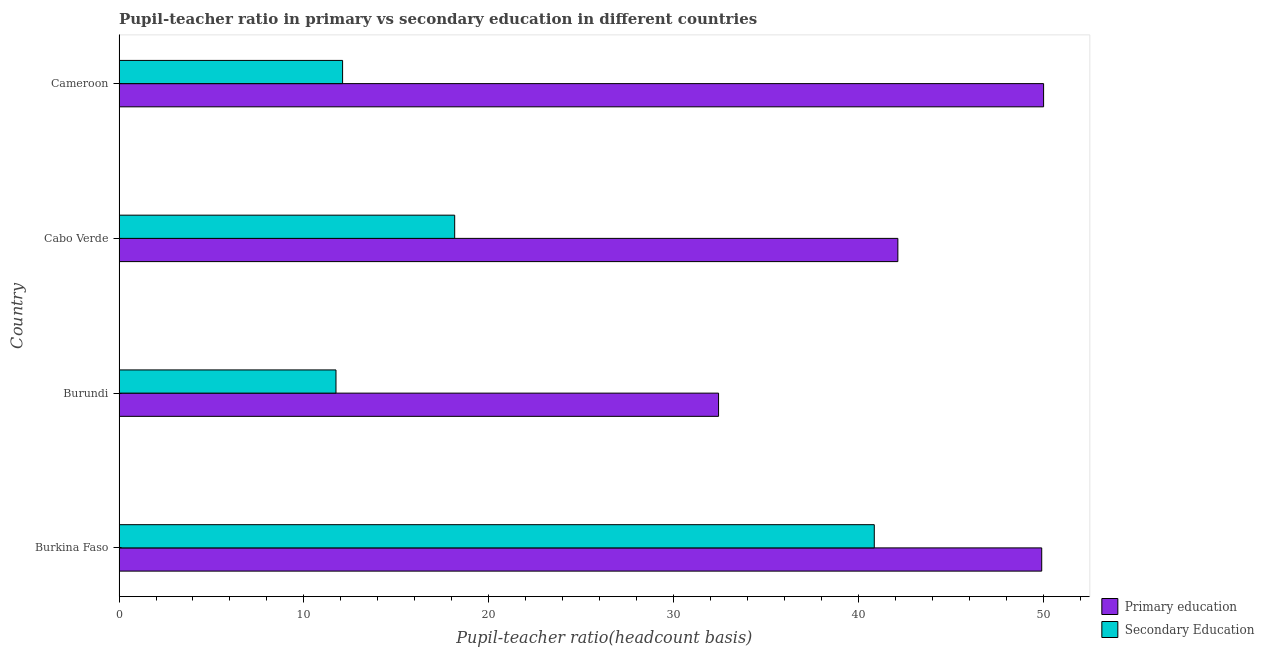How many groups of bars are there?
Ensure brevity in your answer.  4. Are the number of bars per tick equal to the number of legend labels?
Provide a succinct answer. Yes. How many bars are there on the 1st tick from the top?
Keep it short and to the point. 2. How many bars are there on the 4th tick from the bottom?
Offer a very short reply. 2. What is the label of the 2nd group of bars from the top?
Provide a short and direct response. Cabo Verde. In how many cases, is the number of bars for a given country not equal to the number of legend labels?
Provide a short and direct response. 0. What is the pupil teacher ratio on secondary education in Burundi?
Your answer should be compact. 11.74. Across all countries, what is the maximum pupil-teacher ratio in primary education?
Keep it short and to the point. 50.02. Across all countries, what is the minimum pupil-teacher ratio in primary education?
Give a very brief answer. 32.44. In which country was the pupil teacher ratio on secondary education maximum?
Your answer should be compact. Burkina Faso. In which country was the pupil teacher ratio on secondary education minimum?
Keep it short and to the point. Burundi. What is the total pupil teacher ratio on secondary education in the graph?
Offer a very short reply. 82.85. What is the difference between the pupil-teacher ratio in primary education in Burkina Faso and that in Cabo Verde?
Offer a terse response. 7.78. What is the difference between the pupil teacher ratio on secondary education in Burundi and the pupil-teacher ratio in primary education in Burkina Faso?
Keep it short and to the point. -38.18. What is the average pupil teacher ratio on secondary education per country?
Give a very brief answer. 20.71. What is the difference between the pupil teacher ratio on secondary education and pupil-teacher ratio in primary education in Burundi?
Make the answer very short. -20.7. In how many countries, is the pupil teacher ratio on secondary education greater than 26 ?
Your answer should be very brief. 1. What is the ratio of the pupil-teacher ratio in primary education in Burundi to that in Cabo Verde?
Make the answer very short. 0.77. What is the difference between the highest and the second highest pupil-teacher ratio in primary education?
Provide a succinct answer. 0.1. What is the difference between the highest and the lowest pupil-teacher ratio in primary education?
Make the answer very short. 17.59. In how many countries, is the pupil teacher ratio on secondary education greater than the average pupil teacher ratio on secondary education taken over all countries?
Make the answer very short. 1. What does the 1st bar from the top in Burkina Faso represents?
Your response must be concise. Secondary Education. What does the 1st bar from the bottom in Cameroon represents?
Your answer should be compact. Primary education. Are all the bars in the graph horizontal?
Give a very brief answer. Yes. How many countries are there in the graph?
Your response must be concise. 4. What is the difference between two consecutive major ticks on the X-axis?
Your answer should be compact. 10. Are the values on the major ticks of X-axis written in scientific E-notation?
Your answer should be very brief. No. Does the graph contain any zero values?
Your response must be concise. No. How many legend labels are there?
Your answer should be very brief. 2. How are the legend labels stacked?
Provide a short and direct response. Vertical. What is the title of the graph?
Give a very brief answer. Pupil-teacher ratio in primary vs secondary education in different countries. Does "Netherlands" appear as one of the legend labels in the graph?
Keep it short and to the point. No. What is the label or title of the X-axis?
Ensure brevity in your answer.  Pupil-teacher ratio(headcount basis). What is the Pupil-teacher ratio(headcount basis) in Primary education in Burkina Faso?
Provide a short and direct response. 49.92. What is the Pupil-teacher ratio(headcount basis) in Secondary Education in Burkina Faso?
Keep it short and to the point. 40.86. What is the Pupil-teacher ratio(headcount basis) of Primary education in Burundi?
Your response must be concise. 32.44. What is the Pupil-teacher ratio(headcount basis) in Secondary Education in Burundi?
Keep it short and to the point. 11.74. What is the Pupil-teacher ratio(headcount basis) in Primary education in Cabo Verde?
Ensure brevity in your answer.  42.14. What is the Pupil-teacher ratio(headcount basis) of Secondary Education in Cabo Verde?
Your answer should be compact. 18.16. What is the Pupil-teacher ratio(headcount basis) of Primary education in Cameroon?
Make the answer very short. 50.02. What is the Pupil-teacher ratio(headcount basis) of Secondary Education in Cameroon?
Provide a short and direct response. 12.09. Across all countries, what is the maximum Pupil-teacher ratio(headcount basis) in Primary education?
Ensure brevity in your answer.  50.02. Across all countries, what is the maximum Pupil-teacher ratio(headcount basis) in Secondary Education?
Offer a terse response. 40.86. Across all countries, what is the minimum Pupil-teacher ratio(headcount basis) of Primary education?
Your answer should be compact. 32.44. Across all countries, what is the minimum Pupil-teacher ratio(headcount basis) in Secondary Education?
Offer a very short reply. 11.74. What is the total Pupil-teacher ratio(headcount basis) in Primary education in the graph?
Give a very brief answer. 174.52. What is the total Pupil-teacher ratio(headcount basis) in Secondary Education in the graph?
Your answer should be very brief. 82.85. What is the difference between the Pupil-teacher ratio(headcount basis) of Primary education in Burkina Faso and that in Burundi?
Make the answer very short. 17.48. What is the difference between the Pupil-teacher ratio(headcount basis) of Secondary Education in Burkina Faso and that in Burundi?
Your response must be concise. 29.12. What is the difference between the Pupil-teacher ratio(headcount basis) of Primary education in Burkina Faso and that in Cabo Verde?
Keep it short and to the point. 7.78. What is the difference between the Pupil-teacher ratio(headcount basis) of Secondary Education in Burkina Faso and that in Cabo Verde?
Offer a terse response. 22.7. What is the difference between the Pupil-teacher ratio(headcount basis) of Primary education in Burkina Faso and that in Cameroon?
Ensure brevity in your answer.  -0.1. What is the difference between the Pupil-teacher ratio(headcount basis) in Secondary Education in Burkina Faso and that in Cameroon?
Your answer should be very brief. 28.77. What is the difference between the Pupil-teacher ratio(headcount basis) in Primary education in Burundi and that in Cabo Verde?
Your answer should be compact. -9.7. What is the difference between the Pupil-teacher ratio(headcount basis) in Secondary Education in Burundi and that in Cabo Verde?
Give a very brief answer. -6.42. What is the difference between the Pupil-teacher ratio(headcount basis) in Primary education in Burundi and that in Cameroon?
Make the answer very short. -17.59. What is the difference between the Pupil-teacher ratio(headcount basis) in Secondary Education in Burundi and that in Cameroon?
Provide a short and direct response. -0.36. What is the difference between the Pupil-teacher ratio(headcount basis) in Primary education in Cabo Verde and that in Cameroon?
Offer a very short reply. -7.89. What is the difference between the Pupil-teacher ratio(headcount basis) in Secondary Education in Cabo Verde and that in Cameroon?
Your answer should be compact. 6.07. What is the difference between the Pupil-teacher ratio(headcount basis) in Primary education in Burkina Faso and the Pupil-teacher ratio(headcount basis) in Secondary Education in Burundi?
Your answer should be compact. 38.18. What is the difference between the Pupil-teacher ratio(headcount basis) of Primary education in Burkina Faso and the Pupil-teacher ratio(headcount basis) of Secondary Education in Cabo Verde?
Make the answer very short. 31.76. What is the difference between the Pupil-teacher ratio(headcount basis) in Primary education in Burkina Faso and the Pupil-teacher ratio(headcount basis) in Secondary Education in Cameroon?
Provide a succinct answer. 37.83. What is the difference between the Pupil-teacher ratio(headcount basis) of Primary education in Burundi and the Pupil-teacher ratio(headcount basis) of Secondary Education in Cabo Verde?
Your answer should be compact. 14.28. What is the difference between the Pupil-teacher ratio(headcount basis) of Primary education in Burundi and the Pupil-teacher ratio(headcount basis) of Secondary Education in Cameroon?
Keep it short and to the point. 20.34. What is the difference between the Pupil-teacher ratio(headcount basis) of Primary education in Cabo Verde and the Pupil-teacher ratio(headcount basis) of Secondary Education in Cameroon?
Your answer should be very brief. 30.04. What is the average Pupil-teacher ratio(headcount basis) of Primary education per country?
Your answer should be very brief. 43.63. What is the average Pupil-teacher ratio(headcount basis) of Secondary Education per country?
Your answer should be very brief. 20.71. What is the difference between the Pupil-teacher ratio(headcount basis) of Primary education and Pupil-teacher ratio(headcount basis) of Secondary Education in Burkina Faso?
Ensure brevity in your answer.  9.06. What is the difference between the Pupil-teacher ratio(headcount basis) in Primary education and Pupil-teacher ratio(headcount basis) in Secondary Education in Burundi?
Ensure brevity in your answer.  20.7. What is the difference between the Pupil-teacher ratio(headcount basis) in Primary education and Pupil-teacher ratio(headcount basis) in Secondary Education in Cabo Verde?
Your answer should be compact. 23.98. What is the difference between the Pupil-teacher ratio(headcount basis) of Primary education and Pupil-teacher ratio(headcount basis) of Secondary Education in Cameroon?
Your answer should be very brief. 37.93. What is the ratio of the Pupil-teacher ratio(headcount basis) in Primary education in Burkina Faso to that in Burundi?
Keep it short and to the point. 1.54. What is the ratio of the Pupil-teacher ratio(headcount basis) of Secondary Education in Burkina Faso to that in Burundi?
Offer a very short reply. 3.48. What is the ratio of the Pupil-teacher ratio(headcount basis) of Primary education in Burkina Faso to that in Cabo Verde?
Provide a short and direct response. 1.18. What is the ratio of the Pupil-teacher ratio(headcount basis) in Secondary Education in Burkina Faso to that in Cabo Verde?
Ensure brevity in your answer.  2.25. What is the ratio of the Pupil-teacher ratio(headcount basis) in Secondary Education in Burkina Faso to that in Cameroon?
Your answer should be very brief. 3.38. What is the ratio of the Pupil-teacher ratio(headcount basis) of Primary education in Burundi to that in Cabo Verde?
Keep it short and to the point. 0.77. What is the ratio of the Pupil-teacher ratio(headcount basis) of Secondary Education in Burundi to that in Cabo Verde?
Your answer should be compact. 0.65. What is the ratio of the Pupil-teacher ratio(headcount basis) in Primary education in Burundi to that in Cameroon?
Your answer should be very brief. 0.65. What is the ratio of the Pupil-teacher ratio(headcount basis) in Secondary Education in Burundi to that in Cameroon?
Your answer should be very brief. 0.97. What is the ratio of the Pupil-teacher ratio(headcount basis) in Primary education in Cabo Verde to that in Cameroon?
Ensure brevity in your answer.  0.84. What is the ratio of the Pupil-teacher ratio(headcount basis) in Secondary Education in Cabo Verde to that in Cameroon?
Provide a short and direct response. 1.5. What is the difference between the highest and the second highest Pupil-teacher ratio(headcount basis) in Primary education?
Keep it short and to the point. 0.1. What is the difference between the highest and the second highest Pupil-teacher ratio(headcount basis) of Secondary Education?
Offer a terse response. 22.7. What is the difference between the highest and the lowest Pupil-teacher ratio(headcount basis) of Primary education?
Ensure brevity in your answer.  17.59. What is the difference between the highest and the lowest Pupil-teacher ratio(headcount basis) in Secondary Education?
Provide a short and direct response. 29.12. 